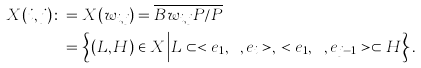<formula> <loc_0><loc_0><loc_500><loc_500>X ( i , j ) \colon & = X ( w _ { i , j } ) = \overline { B w _ { i , j } P / P } \\ & = \left \{ ( L , H ) \in X \Big | L \subset < e _ { 1 } , \cdots , e _ { i } > , \, < e _ { 1 } , \cdots , e _ { j - 1 } > \subset H \right \} .</formula> 